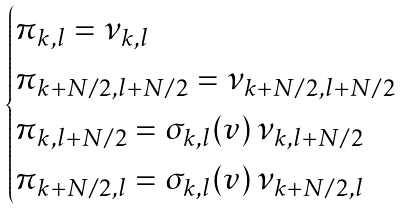Convert formula to latex. <formula><loc_0><loc_0><loc_500><loc_500>\begin{cases} \pi _ { k , l } = \nu _ { k , l } \\ \pi _ { k + N / 2 , l + N / 2 } = \nu _ { k + N / 2 , l + N / 2 } \\ \pi _ { k , l + N / 2 } = \sigma _ { k , l } ( v ) \, \nu _ { k , l + N / 2 } \\ \pi _ { k + N / 2 , l } = \sigma _ { k , l } ( v ) \, \nu _ { k + N / 2 , l } \end{cases}</formula> 